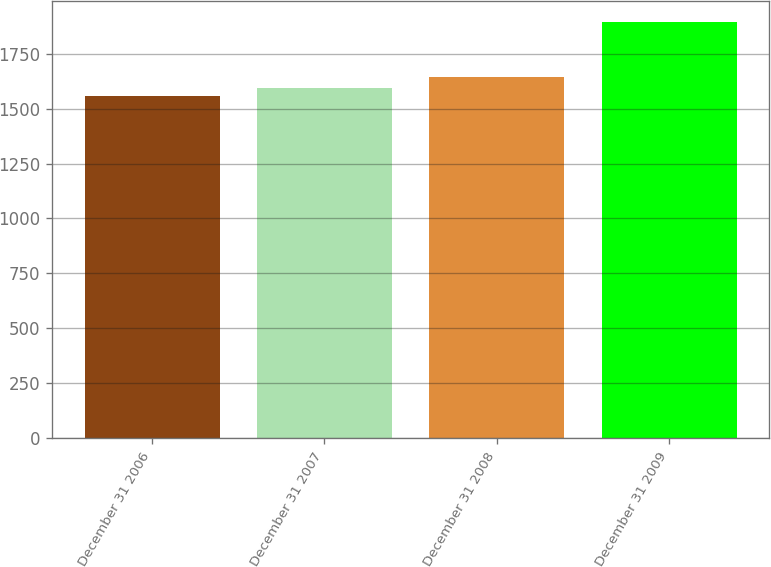Convert chart to OTSL. <chart><loc_0><loc_0><loc_500><loc_500><bar_chart><fcel>December 31 2006<fcel>December 31 2007<fcel>December 31 2008<fcel>December 31 2009<nl><fcel>1559<fcel>1592.7<fcel>1646<fcel>1896<nl></chart> 